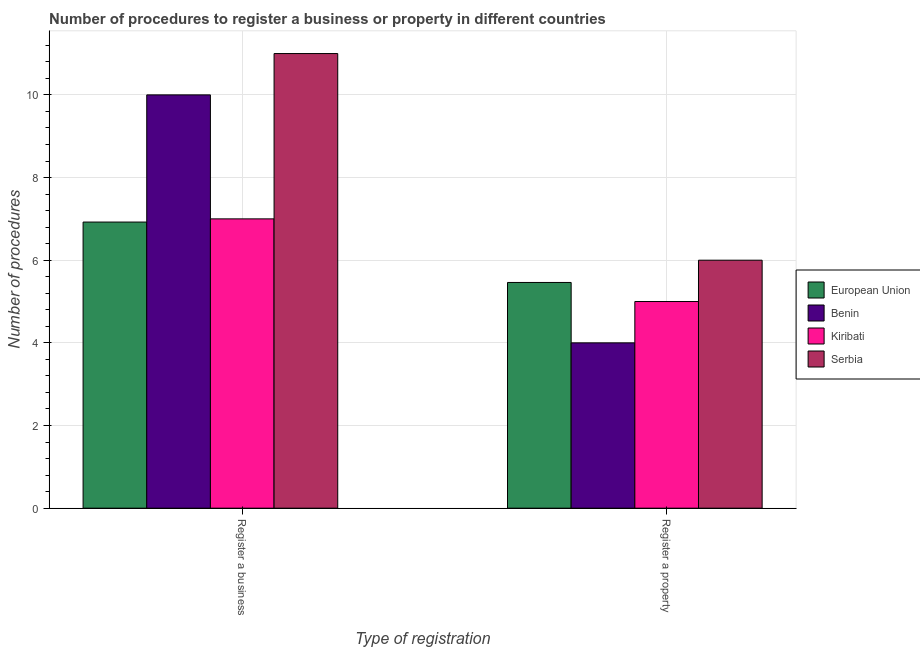Are the number of bars per tick equal to the number of legend labels?
Your answer should be very brief. Yes. What is the label of the 2nd group of bars from the left?
Provide a succinct answer. Register a property. What is the number of procedures to register a property in Serbia?
Give a very brief answer. 6. Across all countries, what is the maximum number of procedures to register a business?
Keep it short and to the point. 11. In which country was the number of procedures to register a property maximum?
Provide a short and direct response. Serbia. In which country was the number of procedures to register a property minimum?
Give a very brief answer. Benin. What is the total number of procedures to register a property in the graph?
Your response must be concise. 20.46. What is the difference between the number of procedures to register a business in Serbia and that in European Union?
Your response must be concise. 4.08. What is the difference between the number of procedures to register a business in Kiribati and the number of procedures to register a property in European Union?
Provide a succinct answer. 1.54. What is the average number of procedures to register a business per country?
Provide a short and direct response. 8.73. What is the difference between the number of procedures to register a business and number of procedures to register a property in Serbia?
Offer a terse response. 5. What is the ratio of the number of procedures to register a business in Benin to that in Kiribati?
Your answer should be compact. 1.43. Is the number of procedures to register a business in Benin less than that in Kiribati?
Offer a very short reply. No. What does the 3rd bar from the left in Register a property represents?
Your answer should be very brief. Kiribati. What does the 1st bar from the right in Register a property represents?
Your response must be concise. Serbia. How many bars are there?
Provide a succinct answer. 8. Are the values on the major ticks of Y-axis written in scientific E-notation?
Make the answer very short. No. Does the graph contain any zero values?
Offer a very short reply. No. Does the graph contain grids?
Offer a very short reply. Yes. What is the title of the graph?
Offer a very short reply. Number of procedures to register a business or property in different countries. What is the label or title of the X-axis?
Ensure brevity in your answer.  Type of registration. What is the label or title of the Y-axis?
Ensure brevity in your answer.  Number of procedures. What is the Number of procedures in European Union in Register a business?
Keep it short and to the point. 6.92. What is the Number of procedures of Kiribati in Register a business?
Your answer should be compact. 7. What is the Number of procedures in Serbia in Register a business?
Keep it short and to the point. 11. What is the Number of procedures in European Union in Register a property?
Make the answer very short. 5.46. What is the Number of procedures in Benin in Register a property?
Your answer should be compact. 4. What is the Number of procedures in Serbia in Register a property?
Ensure brevity in your answer.  6. Across all Type of registration, what is the maximum Number of procedures of European Union?
Provide a short and direct response. 6.92. Across all Type of registration, what is the maximum Number of procedures of Benin?
Provide a short and direct response. 10. Across all Type of registration, what is the maximum Number of procedures in Kiribati?
Keep it short and to the point. 7. Across all Type of registration, what is the minimum Number of procedures in European Union?
Provide a succinct answer. 5.46. Across all Type of registration, what is the minimum Number of procedures of Benin?
Provide a succinct answer. 4. Across all Type of registration, what is the minimum Number of procedures of Kiribati?
Ensure brevity in your answer.  5. Across all Type of registration, what is the minimum Number of procedures in Serbia?
Keep it short and to the point. 6. What is the total Number of procedures in European Union in the graph?
Give a very brief answer. 12.38. What is the total Number of procedures of Benin in the graph?
Your answer should be very brief. 14. What is the total Number of procedures in Kiribati in the graph?
Make the answer very short. 12. What is the difference between the Number of procedures of European Union in Register a business and that in Register a property?
Make the answer very short. 1.46. What is the difference between the Number of procedures in Serbia in Register a business and that in Register a property?
Your response must be concise. 5. What is the difference between the Number of procedures of European Union in Register a business and the Number of procedures of Benin in Register a property?
Provide a short and direct response. 2.92. What is the difference between the Number of procedures in European Union in Register a business and the Number of procedures in Kiribati in Register a property?
Offer a terse response. 1.92. What is the difference between the Number of procedures in European Union in Register a business and the Number of procedures in Serbia in Register a property?
Your response must be concise. 0.92. What is the difference between the Number of procedures in Benin in Register a business and the Number of procedures in Kiribati in Register a property?
Offer a terse response. 5. What is the difference between the Number of procedures in Benin in Register a business and the Number of procedures in Serbia in Register a property?
Give a very brief answer. 4. What is the difference between the Number of procedures in Kiribati in Register a business and the Number of procedures in Serbia in Register a property?
Provide a succinct answer. 1. What is the average Number of procedures of European Union per Type of registration?
Offer a very short reply. 6.19. What is the average Number of procedures in Serbia per Type of registration?
Your answer should be compact. 8.5. What is the difference between the Number of procedures of European Union and Number of procedures of Benin in Register a business?
Provide a succinct answer. -3.08. What is the difference between the Number of procedures of European Union and Number of procedures of Kiribati in Register a business?
Provide a succinct answer. -0.08. What is the difference between the Number of procedures of European Union and Number of procedures of Serbia in Register a business?
Offer a terse response. -4.08. What is the difference between the Number of procedures of Benin and Number of procedures of Kiribati in Register a business?
Make the answer very short. 3. What is the difference between the Number of procedures in Benin and Number of procedures in Serbia in Register a business?
Provide a short and direct response. -1. What is the difference between the Number of procedures of European Union and Number of procedures of Benin in Register a property?
Offer a terse response. 1.46. What is the difference between the Number of procedures of European Union and Number of procedures of Kiribati in Register a property?
Keep it short and to the point. 0.46. What is the difference between the Number of procedures of European Union and Number of procedures of Serbia in Register a property?
Offer a terse response. -0.54. What is the difference between the Number of procedures in Benin and Number of procedures in Kiribati in Register a property?
Offer a very short reply. -1. What is the ratio of the Number of procedures in European Union in Register a business to that in Register a property?
Your answer should be very brief. 1.27. What is the ratio of the Number of procedures in Benin in Register a business to that in Register a property?
Your answer should be compact. 2.5. What is the ratio of the Number of procedures of Kiribati in Register a business to that in Register a property?
Keep it short and to the point. 1.4. What is the ratio of the Number of procedures in Serbia in Register a business to that in Register a property?
Offer a terse response. 1.83. What is the difference between the highest and the second highest Number of procedures in European Union?
Offer a terse response. 1.46. What is the difference between the highest and the second highest Number of procedures of Benin?
Your answer should be compact. 6. What is the difference between the highest and the lowest Number of procedures of European Union?
Ensure brevity in your answer.  1.46. What is the difference between the highest and the lowest Number of procedures in Kiribati?
Make the answer very short. 2. 